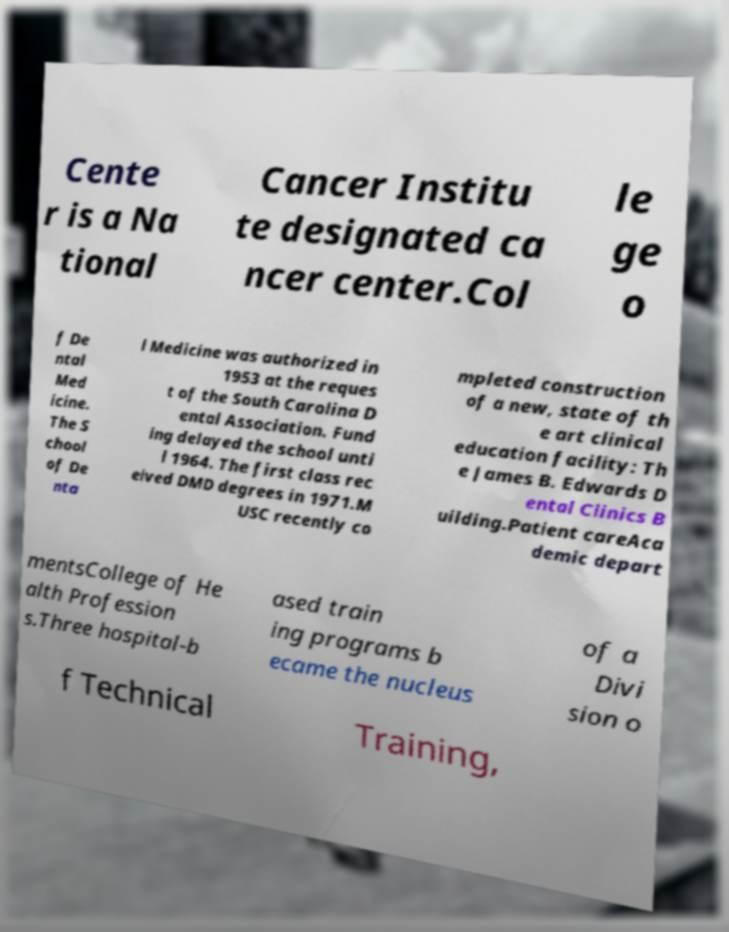Please identify and transcribe the text found in this image. Cente r is a Na tional Cancer Institu te designated ca ncer center.Col le ge o f De ntal Med icine. The S chool of De nta l Medicine was authorized in 1953 at the reques t of the South Carolina D ental Association. Fund ing delayed the school unti l 1964. The first class rec eived DMD degrees in 1971.M USC recently co mpleted construction of a new, state of th e art clinical education facility: Th e James B. Edwards D ental Clinics B uilding.Patient careAca demic depart mentsCollege of He alth Profession s.Three hospital-b ased train ing programs b ecame the nucleus of a Divi sion o f Technical Training, 